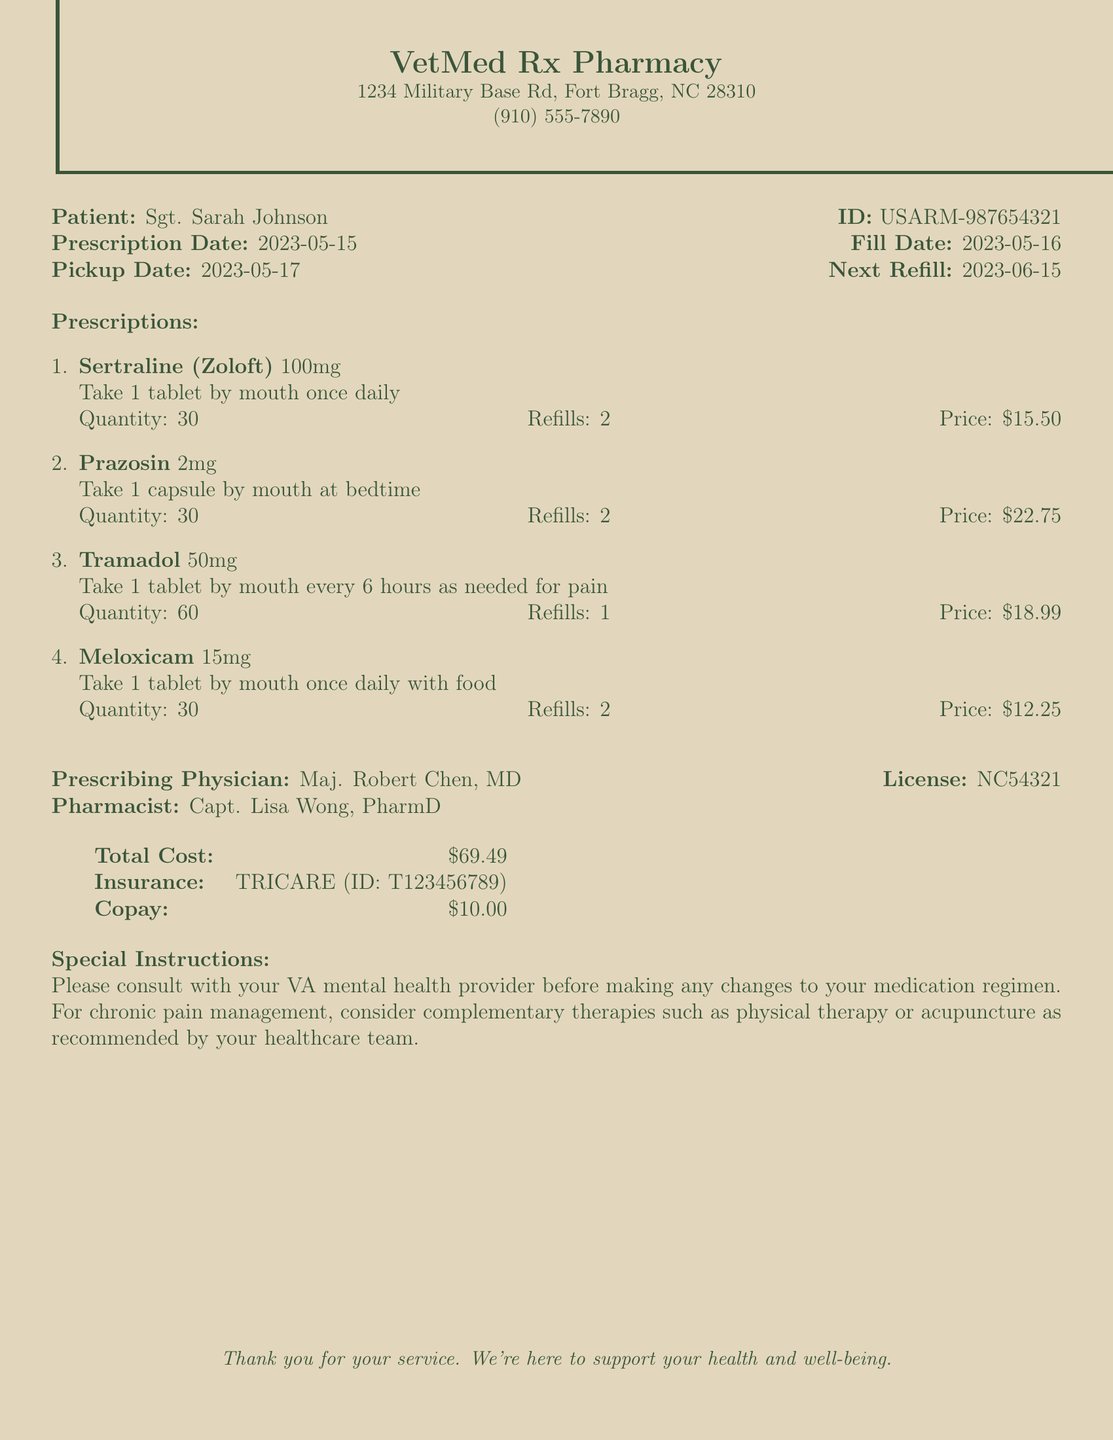what is the pharmacy name? The pharmacy name is listed at the top of the document as the provider of the prescription medications.
Answer: VetMed Rx Pharmacy what is the patient's ID? The patient ID is mentioned alongside the patient's name in the document.
Answer: USARM-987654321 what is the prescription date? The prescription date is clearly stated in the document, indicating when the prescriptions were written.
Answer: 2023-05-15 who is the prescribing physician? The prescribing physician's name is provided in the document, identifying who authored the prescriptions.
Answer: Maj. Robert Chen, MD how many refills are available for Tramadol? The number of refills for Tramadol is noted in the prescription details listed in the document.
Answer: 1 what is the total cost of the prescriptions? The total cost is summarized at the bottom of the document, showing the overall amount due for the prescriptions.
Answer: $69.49 which insurance provider is listed? The insurance provider name is mentioned in the financial section of the document.
Answer: TRICARE what special instructions are provided? Special instructions highlight important considerations regarding medication changes and chronic pain management.
Answer: Please consult with your VA mental health provider before making any changes to your medication regimen. For chronic pain management, consider complementary therapies such as physical therapy or acupuncture as recommended by your healthcare team when is the next refill date? The next refill date is indicated clearly in the document, informing the patient when they can request a new supply.
Answer: 2023-06-15 